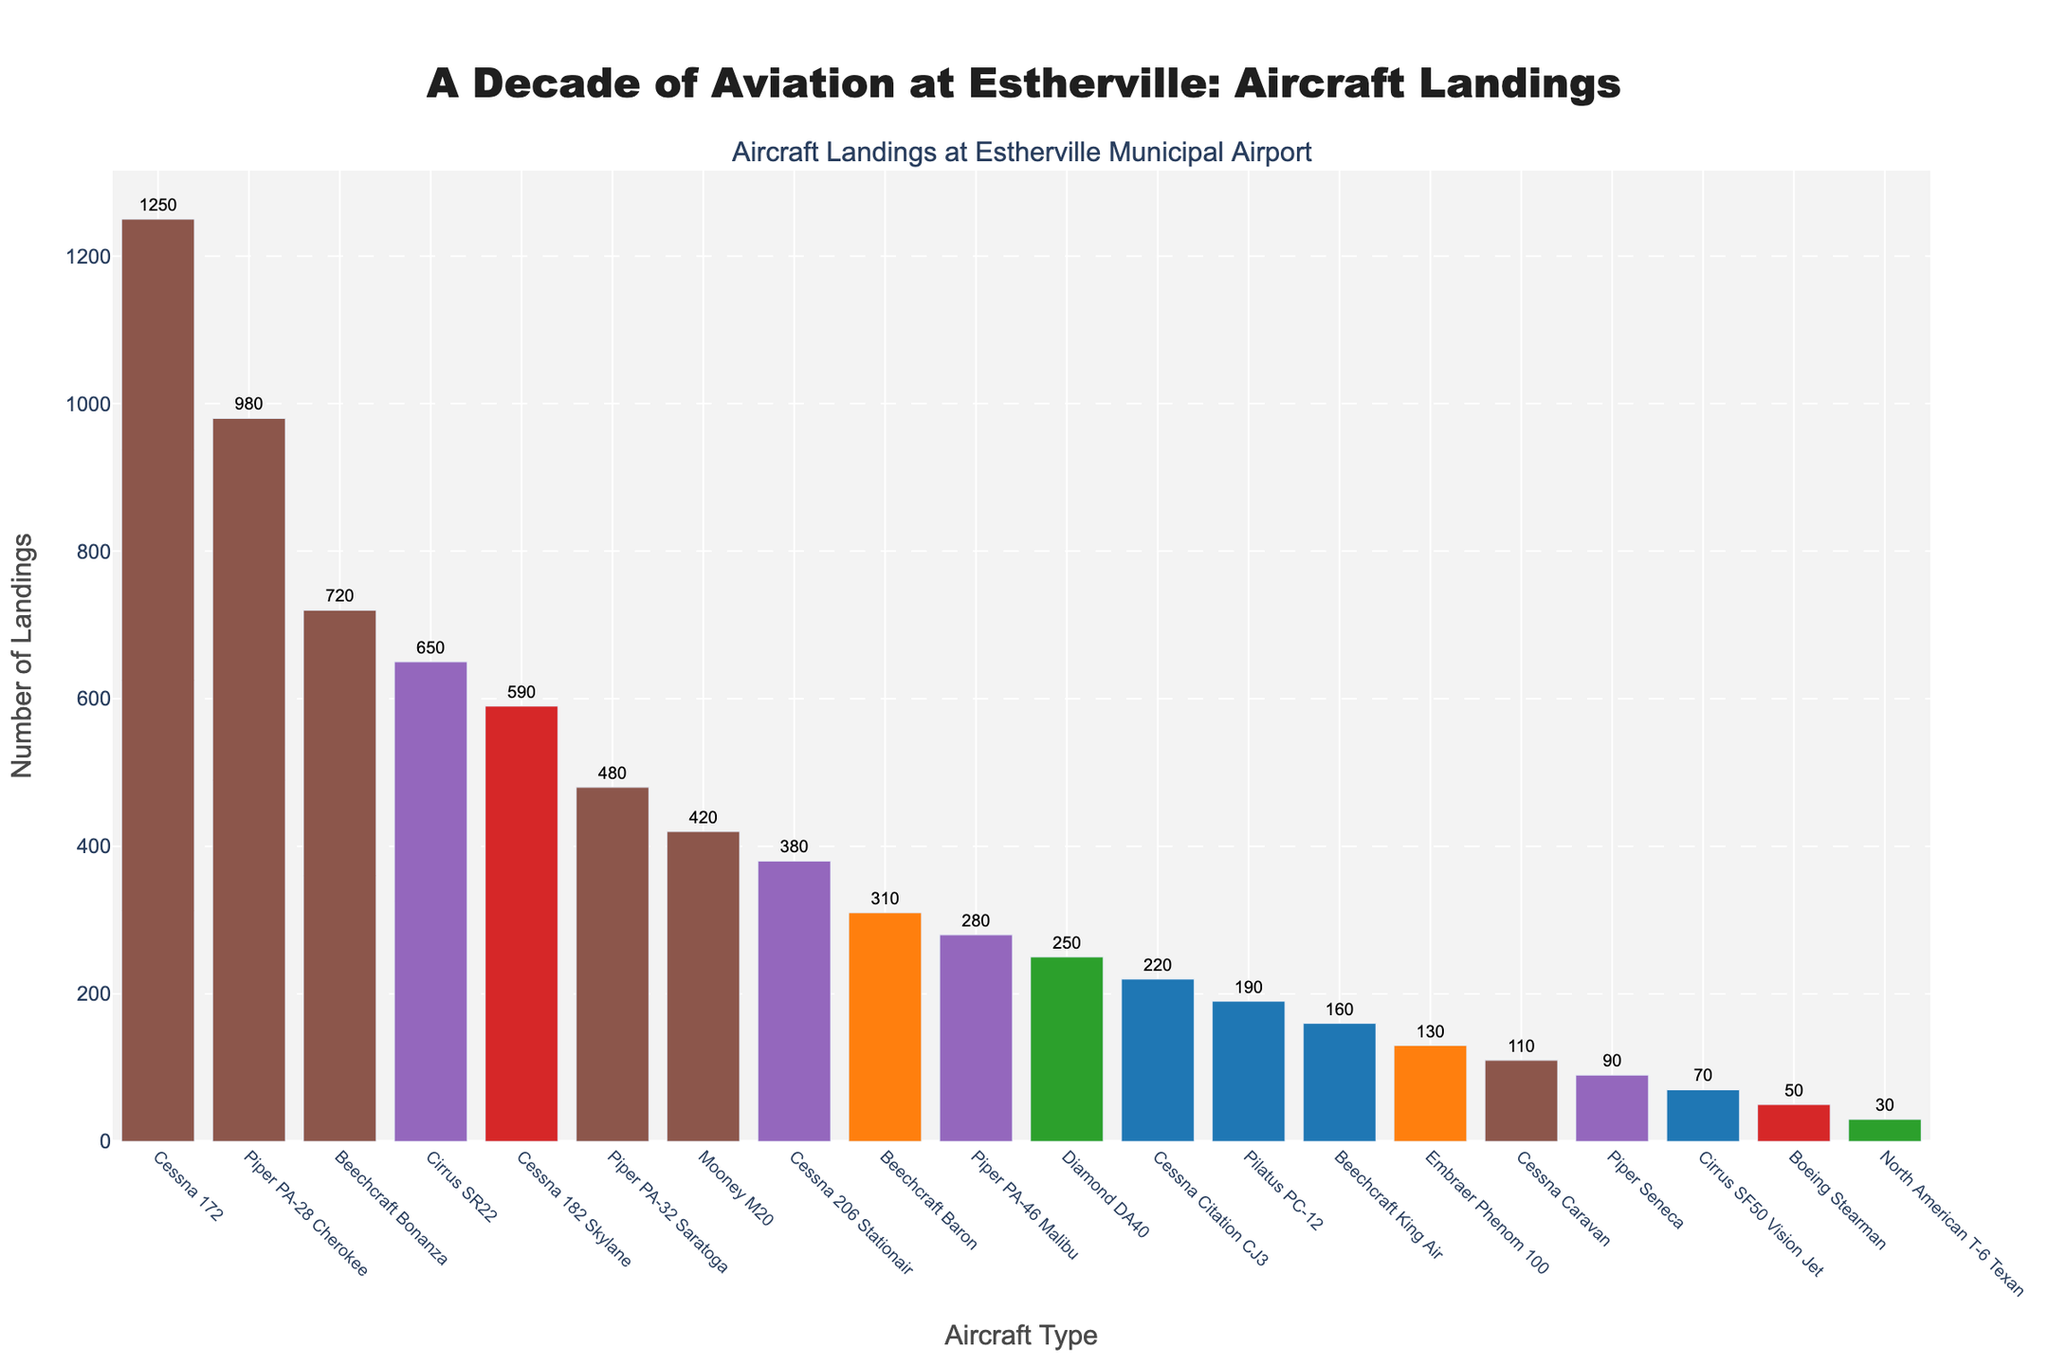Which aircraft type had the highest number of landings at Estherville Municipal Airport over the past decade? Look for the tallest bar in the bar chart. The aircraft type with the highest bar is Cessna 172, indicating it had the highest number of landings.
Answer: Cessna 172 Which two aircraft types had the closest number of landings? Identify bars that are almost equal in height and compare their numeric values. The Piper PA-32 Saratoga and Mooney M20 have very close values, 480 and 420 respectively.
Answer: Piper PA-32 Saratoga and Mooney M20 How many more landings did the Cessna 172 have compared to the Piper PA-28 Cherokee? Find the difference between the number of landings for Cessna 172 and Piper PA-28 Cherokee from the chart. Cessna 172 has 1250 landings and Piper PA-28 Cherokee has 980 landings. The difference is 1250 - 980 = 270.
Answer: 270 What's the total number of landings for all Piper aircraft types listed? Sum the landings for all Piper aircraft types: Piper PA-28 Cherokee (980), Piper PA-32 Saratoga (480), Piper PA-46 Malibu (280), Piper Seneca (90). The total is 980 + 480 + 280 + 90 = 1830.
Answer: 1830 What is the average number of landings for the top three aircraft types? Sum the landings of the top three aircraft types and divide by 3. The top three types are Cessna 172 (1250), Piper PA-28 Cherokee (980), and Beechcraft Bonanza (720). Total is 1250 + 980 + 720 = 2950. The average is 2950 / 3 = 983.33.
Answer: 983.33 Which aircraft type had the lowest number of landings? Locate the shortest bar on the bar chart. The aircraft type with the lowest number of landings is North American T-6 Texan with 30 landings.
Answer: North American T-6 Texan How many aircraft types had more than 500 landings? Count the bars that exceed the 500 landings mark. The aircraft types are Cessna 172, Piper PA-28 Cherokee, Beechcraft Bonanza, Cirrus SR22, and Cessna 182 Skylane, totaling 5 types.
Answer: 5 Which aircraft type had fewer landings, the Cessna Citation CJ3 or the Pilatus PC-12? Compare the heights of the bars for these two aircraft types. Cessna Citation CJ3 had 220 landings, and Pilatus PC-12 had 190 landings. Pilatus PC-12 had fewer landings.
Answer: Pilatus PC-12 What is the median number of landings for all aircraft types listed? List all the landing numbers in ascending order: 30, 50, 70, 90, 110, 130, 160, 190, 220, 250, 280, 310, 380, 420, 480, 590, 650, 720, 980, 1250. The middle value (10th and 11th average) is 250 and 280, average (250+280)/2=265.
Answer: 265 